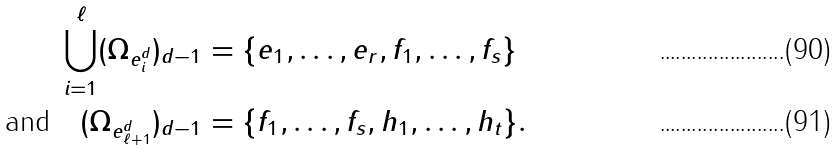Convert formula to latex. <formula><loc_0><loc_0><loc_500><loc_500>\bigcup _ { i = 1 } ^ { \ell } ( \Omega _ { e ^ { d } _ { i } } ) _ { d - 1 } & = \{ e _ { 1 } , \dots , e _ { r } , f _ { 1 } , \dots , f _ { s } \} \\ \text {and} \quad ( \Omega _ { e ^ { d } _ { \ell + 1 } } ) _ { d - 1 } & = \{ f _ { 1 } , \dots , f _ { s } , h _ { 1 } , \dots , h _ { t } \} .</formula> 